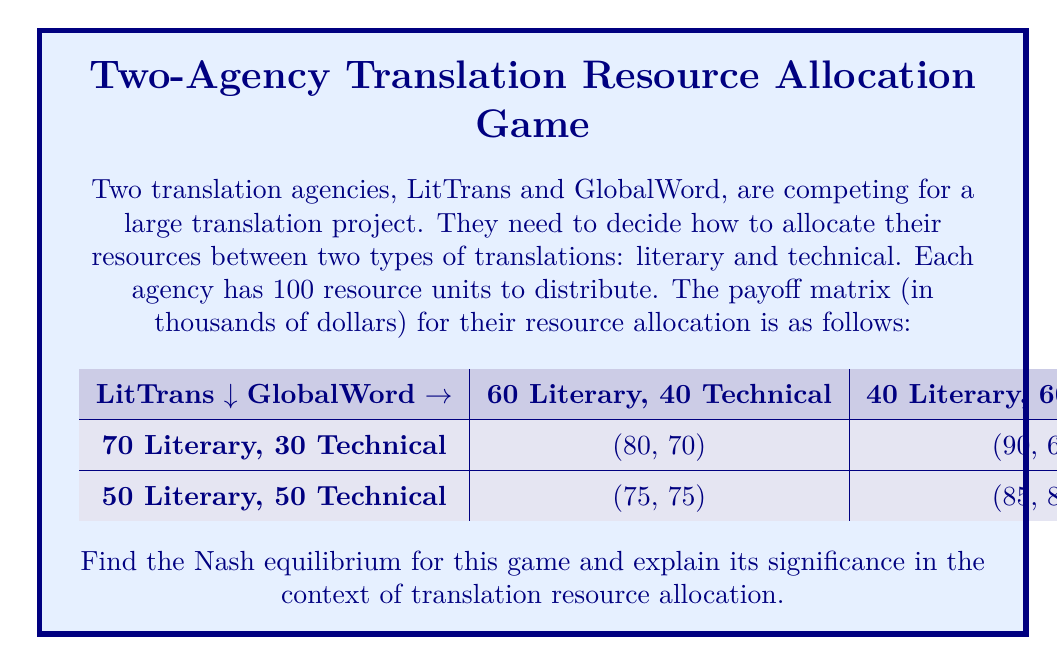Could you help me with this problem? To find the Nash equilibrium, we need to analyze each player's best response to the other player's strategy:

1. For LitTrans:
   - If GlobalWord chooses (60, 40), LitTrans' best response is (70, 30) as 80 > 75
   - If GlobalWord chooses (40, 60), LitTrans' best response is (50, 50) as 85 > 90

2. For GlobalWord:
   - If LitTrans chooses (70, 30), GlobalWord's best response is (40, 60) as 60 < 70
   - If LitTrans chooses (50, 50), GlobalWord's best response is (40, 60) as 80 > 75

We can see that when LitTrans chooses (50, 50) and GlobalWord chooses (40, 60), neither player has an incentive to change their strategy unilaterally. This is the Nash equilibrium.

The Nash equilibrium (50 Literary, 50 Technical) for LitTrans and (40 Literary, 60 Technical) for GlobalWord represents a stable state in the competition between the two agencies. At this point:

1. LitTrans has balanced its resources equally between literary and technical translations, which reflects a diversified approach.
2. GlobalWord has slightly favored technical translations, possibly capitalizing on a perceived strength or market demand.

This equilibrium suggests that in a competitive translation market:

a) Diversification can be a stable strategy for some agencies (like LitTrans).
b) Specialization in certain areas (like GlobalWord's focus on technical translation) can coexist with diversified approaches.
c) The market may naturally lead to a distribution of specializations among competing agencies.

For a literature student interested in translation studies, this equilibrium demonstrates how economic game theory can provide insights into the strategic decisions made by translation agencies in allocating their resources between different types of translation work.
Answer: The Nash equilibrium is:
LitTrans: (50 Literary, 50 Technical)
GlobalWord: (40 Literary, 60 Technical)
Resulting in payoffs of (85, 80) thousand dollars for LitTrans and GlobalWord respectively. 